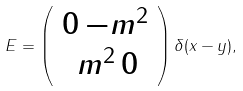<formula> <loc_0><loc_0><loc_500><loc_500>E = \left ( \begin{array} { c } 0 \, { - m ^ { 2 } } \\ \, { m ^ { 2 } } \, 0 \end{array} \right ) \delta ( x - y ) ,</formula> 